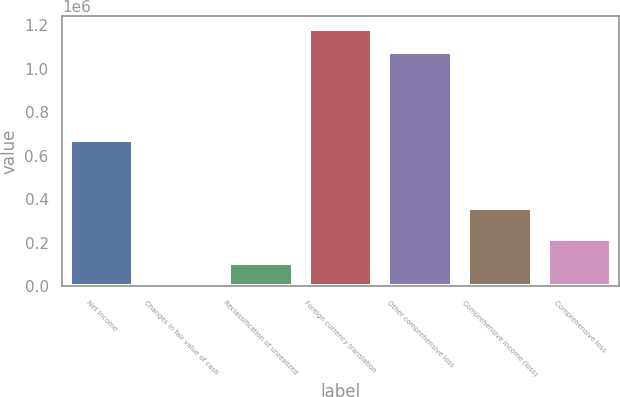Convert chart to OTSL. <chart><loc_0><loc_0><loc_500><loc_500><bar_chart><fcel>Net income<fcel>Changes in fair value of cash<fcel>Reclassification of unrealized<fcel>Foreign currency translation<fcel>Other comprehensive loss<fcel>Comprehensive income (loss)<fcel>Comprehensive loss<nl><fcel>672007<fcel>948<fcel>108748<fcel>1.18336e+06<fcel>1.07556e+06<fcel>357701<fcel>216548<nl></chart> 